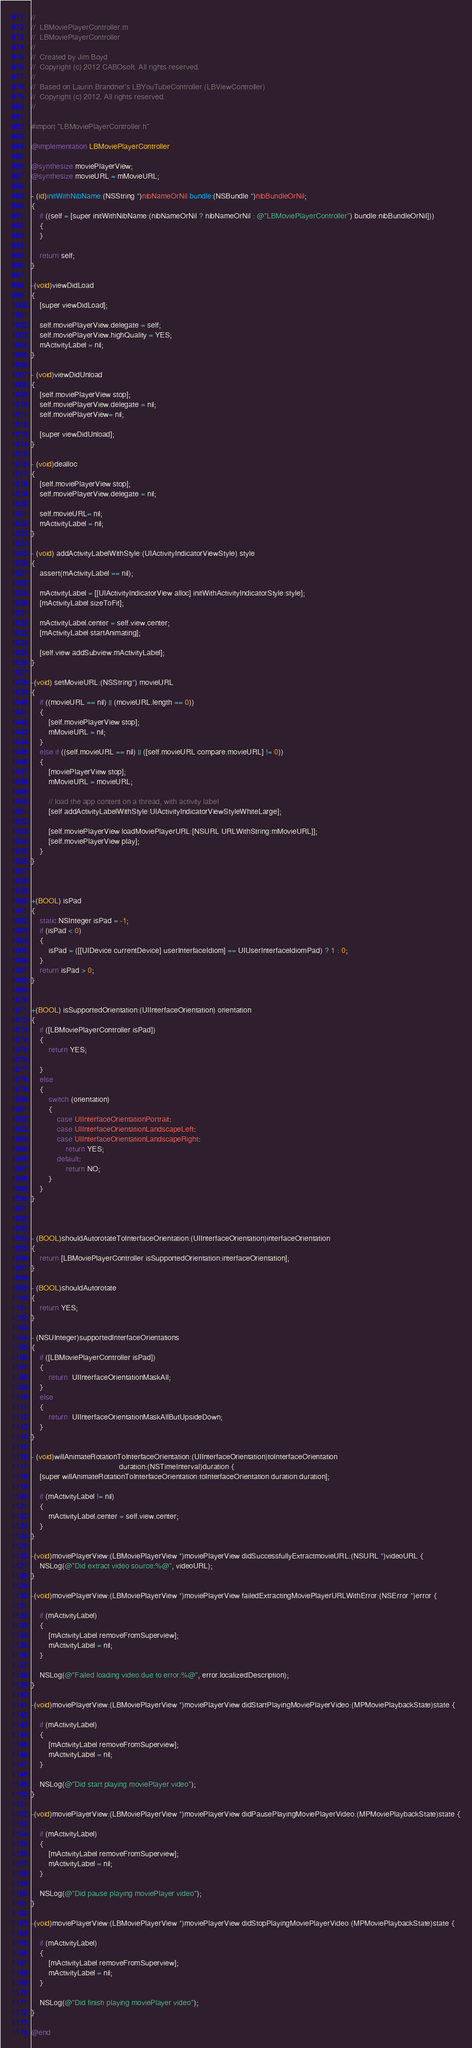Convert code to text. <code><loc_0><loc_0><loc_500><loc_500><_ObjectiveC_>//
//  LBMoviePlayerController.m
//  LBMoviePlayerController
//
//  Created by Jim Boyd
//  Copyright (c) 2012 CABOsoft. All rights reserved.
//
//  Based on Laurin Brandner's LBYouTubeController (LBViewController)
//  Copyright (c) 2012. All rights reserved.
//

#import "LBMoviePlayerController.h"

@implementation LBMoviePlayerController

@synthesize moviePlayerView;
@synthesize movieURL = mMovieURL;

- (id)initWithNibName:(NSString *)nibNameOrNil bundle:(NSBundle *)nibBundleOrNil;
{
	if ((self = [super initWithNibName:(nibNameOrNil ? nibNameOrNil : @"LBMoviePlayerController") bundle:nibBundleOrNil]))
	{
    }
    
    return self;
}

-(void)viewDidLoad 
{
    [super viewDidLoad];
	
    self.moviePlayerView.delegate = self;
    self.moviePlayerView.highQuality = YES;
    mActivityLabel = nil;
}

- (void)viewDidUnload
{
    [self.moviePlayerView stop];        
    self.moviePlayerView.delegate = nil;
    self.moviePlayerView= nil; 

    [super viewDidUnload];
}

- (void)dealloc
{
    [self.moviePlayerView stop];        
    self.moviePlayerView.delegate = nil;
    
    self.movieURL= nil; 
    mActivityLabel = nil;
}

- (void) addActivityLabelWithStyle:(UIActivityIndicatorViewStyle) style
{
    assert(mActivityLabel == nil);
        
    mActivityLabel = [[UIActivityIndicatorView alloc] initWithActivityIndicatorStyle:style];
    [mActivityLabel sizeToFit];
    
    mActivityLabel.center = self.view.center;
    [mActivityLabel startAnimating];

    [self.view addSubview:mActivityLabel];
}

-(void) setMovieURL:(NSString*) movieURL
{
    if ((movieURL == nil) || (movieURL.length == 0))
    {
        [self.moviePlayerView stop];
        mMovieURL = nil;
    }
    else if ((self.movieURL == nil) || ([self.movieURL compare:movieURL] != 0))
    {
        [moviePlayerView stop];  
        mMovieURL = movieURL;
        
        // load the app content on a thread, with activity label
        [self addActivityLabelWithStyle:UIActivityIndicatorViewStyleWhiteLarge];
        
        [self.moviePlayerView loadMoviePlayerURL:[NSURL URLWithString:mMovieURL]];
        [self.moviePlayerView play];
    }
}



+(BOOL) isPad
{
	static NSInteger isPad = -1;
	if (isPad < 0)
	{
		isPad = ([[UIDevice currentDevice] userInterfaceIdiom] == UIUserInterfaceIdiomPad) ? 1 : 0;
	}
	return isPad > 0;
}


+(BOOL) isSupportedOrientation:(UIInterfaceOrientation) orientation
{
	if ([LBMoviePlayerController isPad])
	{
		return YES;
		
	}
	else
	{
		switch (orientation)
		{
			case UIInterfaceOrientationPortrait:
			case UIInterfaceOrientationLandscapeLeft:
			case UIInterfaceOrientationLandscapeRight:
				return YES;
			default:
				return NO;
		}
	}
}



- (BOOL)shouldAutorotateToInterfaceOrientation:(UIInterfaceOrientation)interfaceOrientation 
{
	return [LBMoviePlayerController isSupportedOrientation:interfaceOrientation];
}

- (BOOL)shouldAutorotate
{
    return YES;
}

- (NSUInteger)supportedInterfaceOrientations
{
	if ([LBMoviePlayerController isPad])
    {
        return  UIInterfaceOrientationMaskAll;
    }
    else
    {
        return  UIInterfaceOrientationMaskAllButUpsideDown;
    }
}

- (void)willAnimateRotationToInterfaceOrientation:(UIInterfaceOrientation)toInterfaceOrientation
										 duration:(NSTimeInterval)duration {
	[super willAnimateRotationToInterfaceOrientation:toInterfaceOrientation duration:duration];
	
	if (mActivityLabel != nil)
	{
		mActivityLabel.center = self.view.center;
	}
}

-(void)moviePlayerView:(LBMoviePlayerView *)moviePlayerView didSuccessfullyExtractmovieURL:(NSURL *)videoURL {
    NSLog(@"Did extract video source:%@", videoURL);
}

-(void)moviePlayerView:(LBMoviePlayerView *)moviePlayerView failedExtractingMoviePlayerURLWithError:(NSError *)error {
    
    if (mActivityLabel)
    {
        [mActivityLabel removeFromSuperview];
        mActivityLabel = nil;
    }

    NSLog(@"Failed loading video due to error:%@", error.localizedDescription);
}

-(void)moviePlayerView:(LBMoviePlayerView *)moviePlayerView didStartPlayingMoviePlayerVideo:(MPMoviePlaybackState)state {
    
    if (mActivityLabel)
    {
        [mActivityLabel removeFromSuperview];
        mActivityLabel = nil;
    }

    NSLog(@"Did start playing moviePlayer video");
}

-(void)moviePlayerView:(LBMoviePlayerView *)moviePlayerView didPausePlayingMoviePlayerVideo:(MPMoviePlaybackState)state {
    
    if (mActivityLabel)
    {
        [mActivityLabel removeFromSuperview];
        mActivityLabel = nil;
    }

    NSLog(@"Did pause playing moviePlayer video");
}

-(void)moviePlayerView:(LBMoviePlayerView *)moviePlayerView didStopPlayingMoviePlayerVideo:(MPMoviePlaybackState)state {
    
    if (mActivityLabel)
    {
        [mActivityLabel removeFromSuperview];
        mActivityLabel = nil;
    }

    NSLog(@"Did finish playing moviePlayer video");
}

@end
</code> 